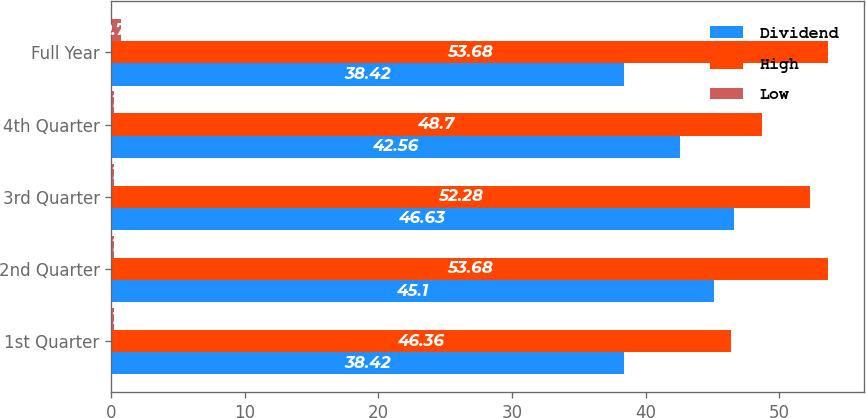<chart> <loc_0><loc_0><loc_500><loc_500><stacked_bar_chart><ecel><fcel>1st Quarter<fcel>2nd Quarter<fcel>3rd Quarter<fcel>4th Quarter<fcel>Full Year<nl><fcel>Dividend<fcel>38.42<fcel>45.1<fcel>46.63<fcel>42.56<fcel>38.42<nl><fcel>High<fcel>46.36<fcel>53.68<fcel>52.28<fcel>48.7<fcel>53.68<nl><fcel>Low<fcel>0.18<fcel>0.18<fcel>0.18<fcel>0.18<fcel>0.71<nl></chart> 